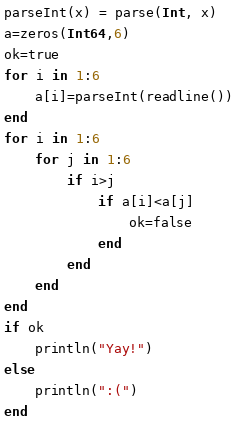Convert code to text. <code><loc_0><loc_0><loc_500><loc_500><_Julia_>parseInt(x) = parse(Int, x)
a=zeros(Int64,6)
ok=true
for i in 1:6
    a[i]=parseInt(readline())
end
for i in 1:6
    for j in 1:6
        if i>j
            if a[i]<a[j]
                ok=false
            end
        end
    end
end
if ok
    println("Yay!")
else
    println(":(")
end</code> 